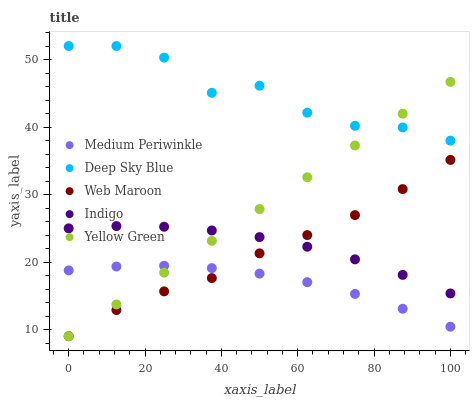Does Medium Periwinkle have the minimum area under the curve?
Answer yes or no. Yes. Does Deep Sky Blue have the maximum area under the curve?
Answer yes or no. Yes. Does Yellow Green have the minimum area under the curve?
Answer yes or no. No. Does Yellow Green have the maximum area under the curve?
Answer yes or no. No. Is Yellow Green the smoothest?
Answer yes or no. Yes. Is Deep Sky Blue the roughest?
Answer yes or no. Yes. Is Medium Periwinkle the smoothest?
Answer yes or no. No. Is Medium Periwinkle the roughest?
Answer yes or no. No. Does Web Maroon have the lowest value?
Answer yes or no. Yes. Does Medium Periwinkle have the lowest value?
Answer yes or no. No. Does Deep Sky Blue have the highest value?
Answer yes or no. Yes. Does Yellow Green have the highest value?
Answer yes or no. No. Is Medium Periwinkle less than Indigo?
Answer yes or no. Yes. Is Deep Sky Blue greater than Web Maroon?
Answer yes or no. Yes. Does Indigo intersect Yellow Green?
Answer yes or no. Yes. Is Indigo less than Yellow Green?
Answer yes or no. No. Is Indigo greater than Yellow Green?
Answer yes or no. No. Does Medium Periwinkle intersect Indigo?
Answer yes or no. No. 